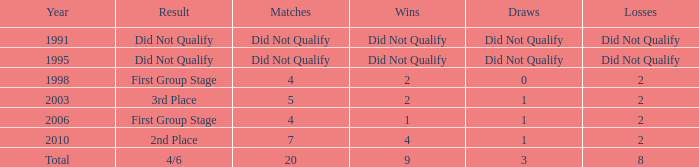In 1998, which games took place during the initial group stage where the teams finished? 4.0. 